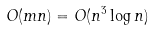<formula> <loc_0><loc_0><loc_500><loc_500>O ( m n ) = O ( n ^ { 3 } \log n )</formula> 